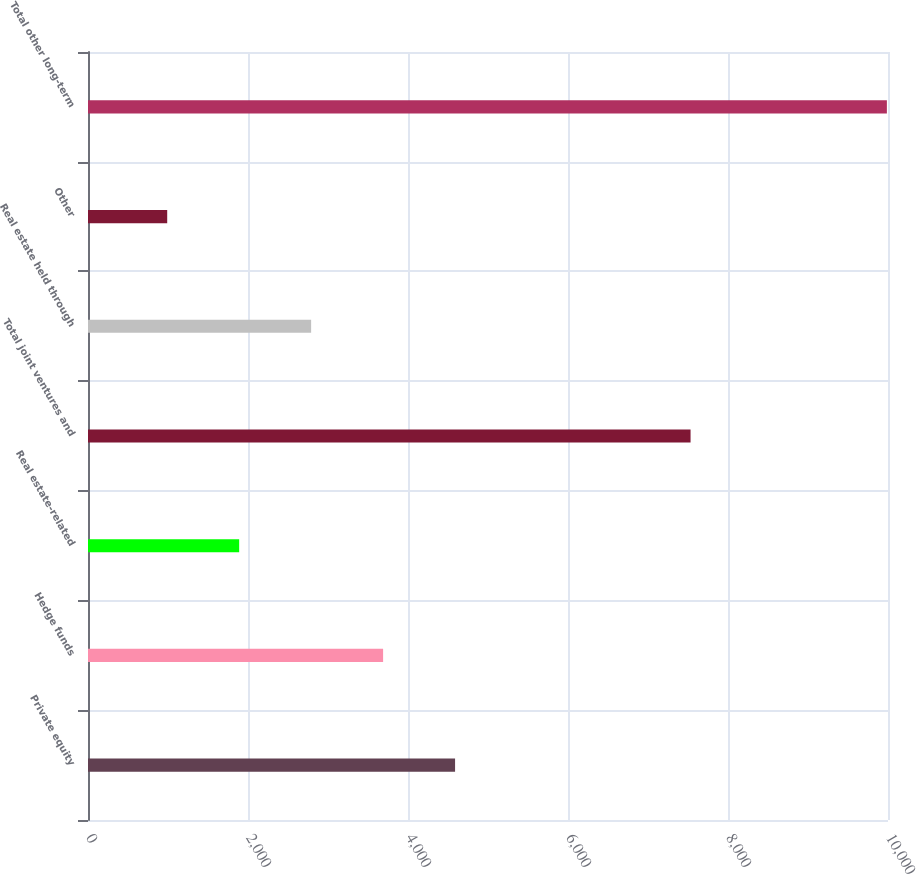Convert chart. <chart><loc_0><loc_0><loc_500><loc_500><bar_chart><fcel>Private equity<fcel>Hedge funds<fcel>Real estate-related<fcel>Total joint ventures and<fcel>Real estate held through<fcel>Other<fcel>Total other long-term<nl><fcel>4588.4<fcel>3688.8<fcel>1889.6<fcel>7532<fcel>2789.2<fcel>990<fcel>9986<nl></chart> 